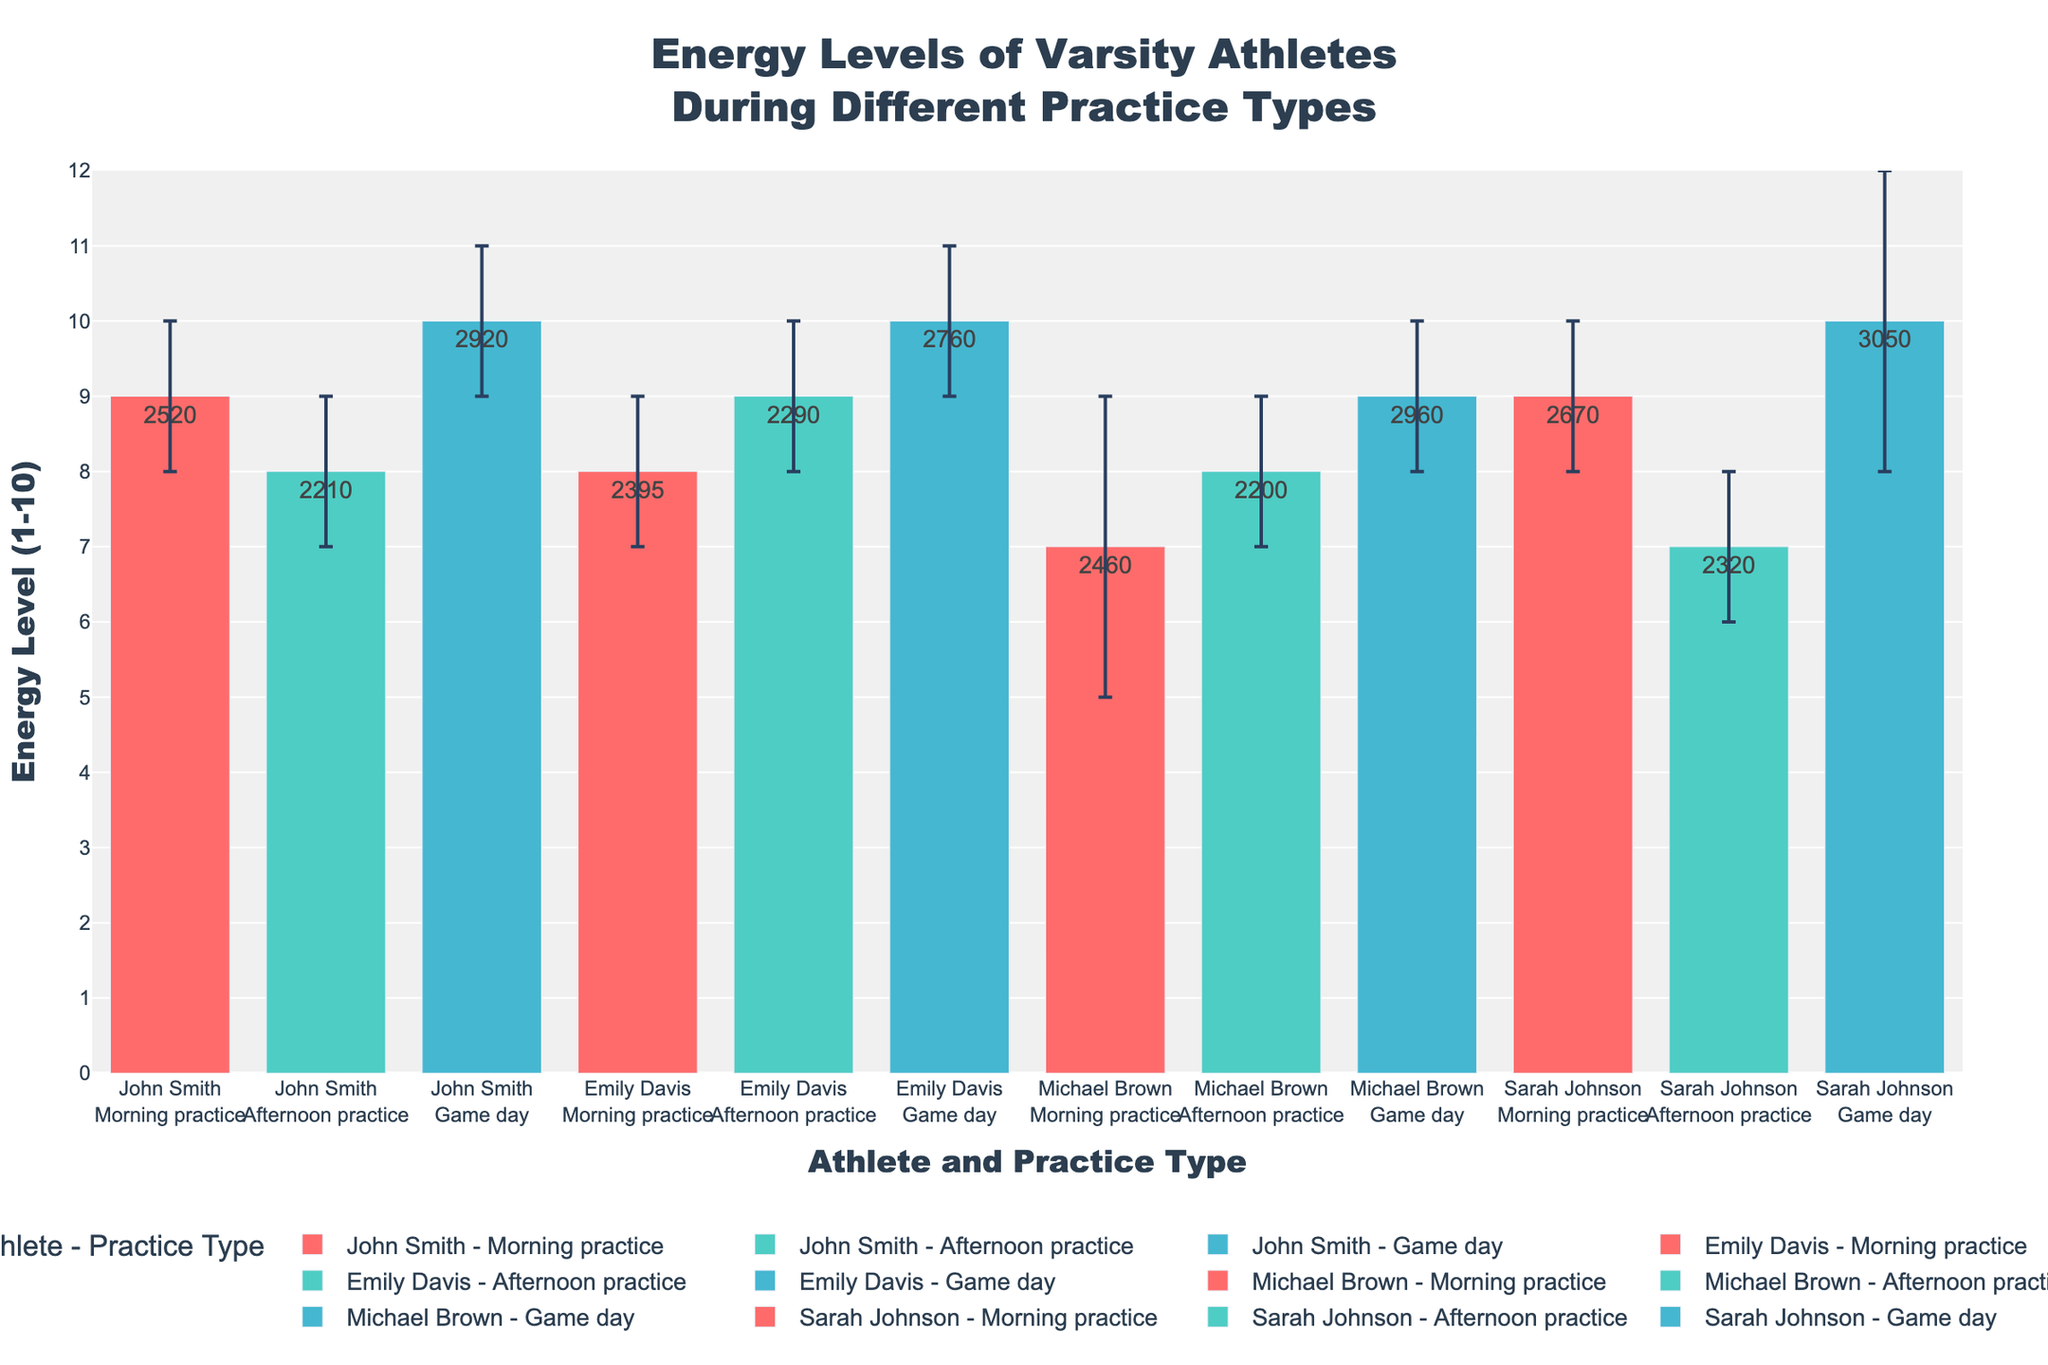How many different practice types are shown in the figure? The legend and x-axis display data for different practice types. There are three practice types: Morning practice, Afternoon practice, and Game day.
Answer: Three What does the y-axis represent? The y-axis is labeled "Energy Level (1-10)," which means it represents the energy levels of the athletes on a scale from 1 to 10.
Answer: Energy Level (1-10) Which athlete has the highest energy level on Game day? By looking at the bars labeled "Game day" for each athlete, John Smith, Michael Brown, Sarah Johnson, and Emily Davis all have the maximum energy level of 10 on Game day.
Answer: John Smith, Michael Brown, Sarah Johnson, Emily Davis What is the error margin for Sarah Johnson's Morning practice energy level? The hover template data or the error bars around Sarah Johnson's Morning practice bar will show the error margin. It indicates an error margin of +/-1 for Sarah Johnson's Morning practice.
Answer: +/-1 Who has the lowest energy level during Afternoon practices? By comparing the height of the bars for Afternoon practices, Sarah Johnson has the lowest energy level at 7.
Answer: Sarah Johnson On average, which practice type results in the highest energy level for all athletes? To find this, average the energy levels of all athletes for each practice type. Morning practice: 9+8+7+9=33, Afternoon practice: 8+9+8+7=32, Game day: 10+10+9+10=39. Game day has the highest total, and dividing by 4 athletes, Morning practice: 33/4=8.25, Afternoon practice: 32/4=8, Game day: 39/4=9.75.
Answer: Game day Is there any athlete whose energy level decreases from Morning practice to Afternoon practice and then increases on Game day? Each athlete's energy level trajectory can be observed: John Smith (9->8->10), Emily Davis (8->9->10), Michael Brown (7->8->9), Sarah Johnson (9->7->10). Sarah Johnson's energy level decreases from Morning practice to Afternoon practice and then increases on Game day.
Answer: Sarah Johnson Which practice type has the most consistent energy levels across all athletes? Evaluate the error margins and the spread of energy levels. Morning practice error margins are mostly +/-1 with energy levels ranging narrowly (7-9), Afternoon practice and Game day ranges have varied energy levels and error margins. Morning practice seems the most consistent.
Answer: Morning practice How do John Smith's energy levels on Game day compare to his energy levels during Morning and Afternoon practices? By checking the height of John Smith's bars, his energy level on Game day is 10, higher than the Morning practice (9) and Afternoon practice (8).
Answer: Game day is higher than Morning and Afternoon practices Which athlete's energy level is closest to 8 during Morning practice? By checking the bars for Morning practice energy levels, Emily Davis has an energy level of 8 during Morning practice.
Answer: Emily Davis 